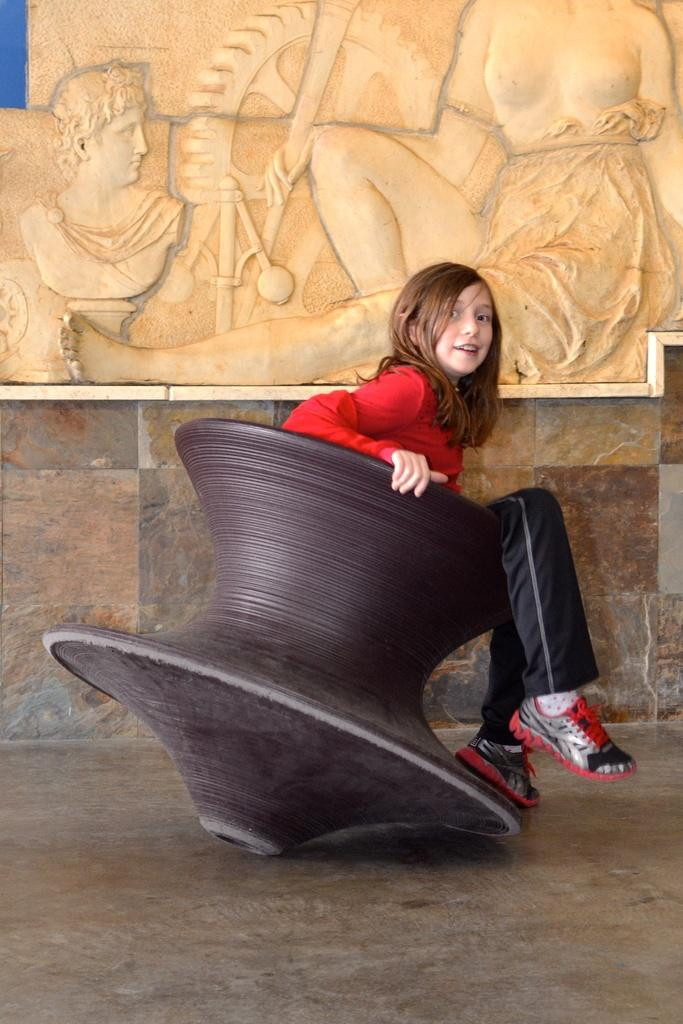What is the main subject of the image? There is a child in the image. What is the child wearing? The child is wearing a red dress and shoes. What is the child sitting on? The child is sitting in a brown object. What can be seen in the background of the image? There is a sculpture on a stone wall in the background of the image. What type of watch is the child wearing in the image? There is no watch visible on the child in the image. Can you describe the ear of the child in the image? The image does not show the child's ear, so it cannot be described. 